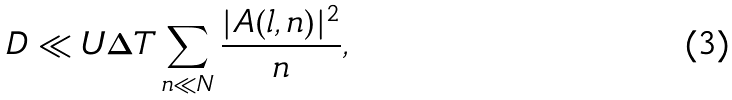<formula> <loc_0><loc_0><loc_500><loc_500>D \ll U \Delta T \sum _ { n \ll N } \frac { | A ( l , n ) | ^ { 2 } } { n } ,</formula> 